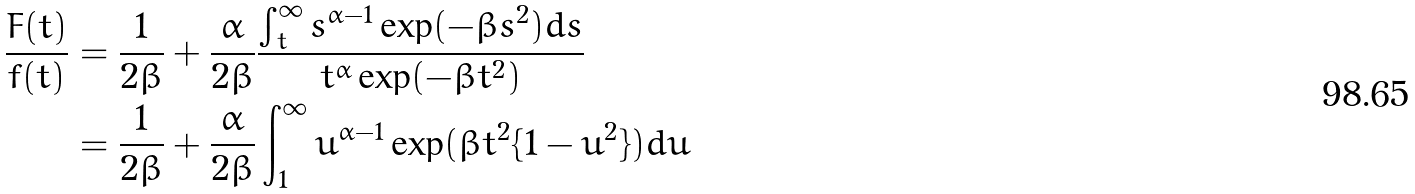<formula> <loc_0><loc_0><loc_500><loc_500>\frac { F ( t ) } { f ( t ) } & = \frac { 1 } { 2 \beta } + \frac { \alpha } { 2 \beta } \frac { \int _ { t } ^ { \infty } s ^ { \alpha - 1 } \exp ( - \beta s ^ { 2 } ) d s } { t ^ { \alpha } \exp ( - \beta t ^ { 2 } ) } \\ & = \frac { 1 } { 2 \beta } + \frac { \alpha } { 2 \beta } \int _ { 1 } ^ { \infty } u ^ { \alpha - 1 } \exp ( \beta t ^ { 2 } \{ 1 - u ^ { 2 } \} ) d u</formula> 